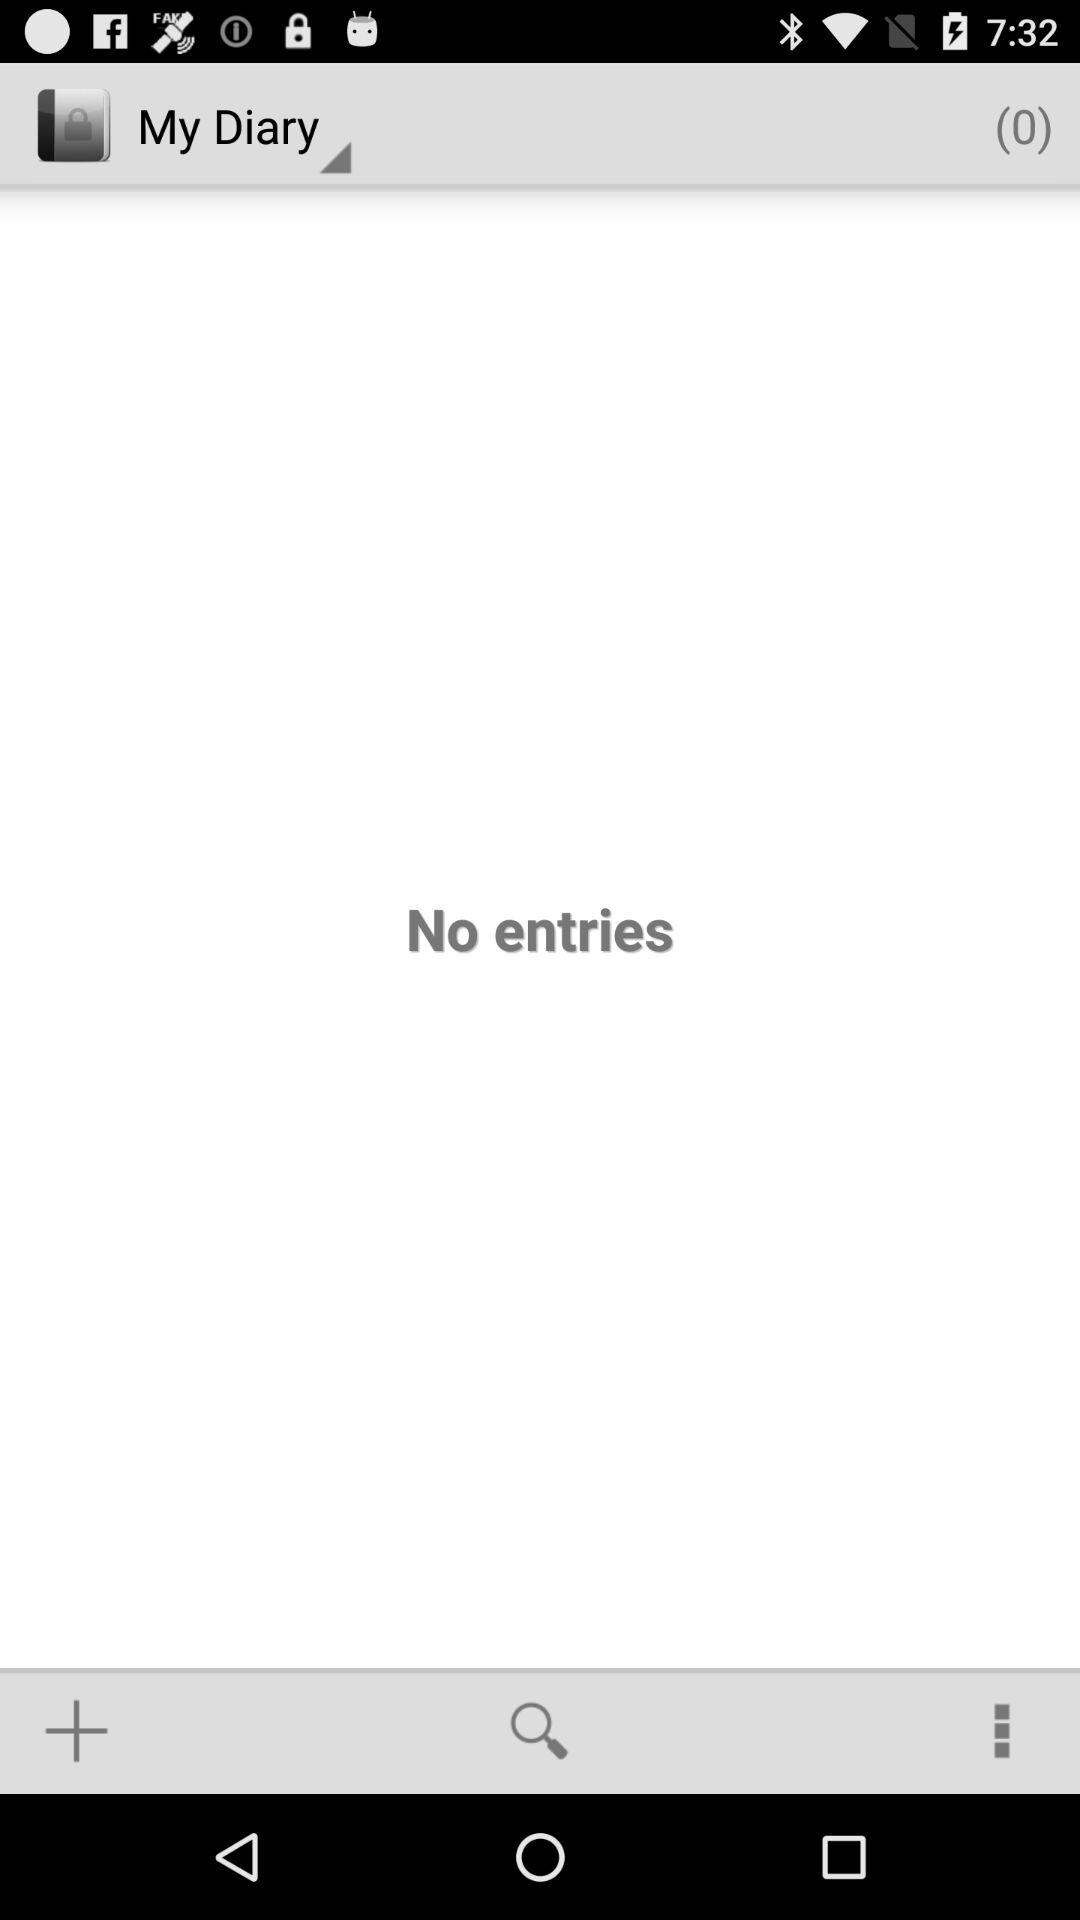What is the number of entries in my diary? The number of entries in your diary is 0. 